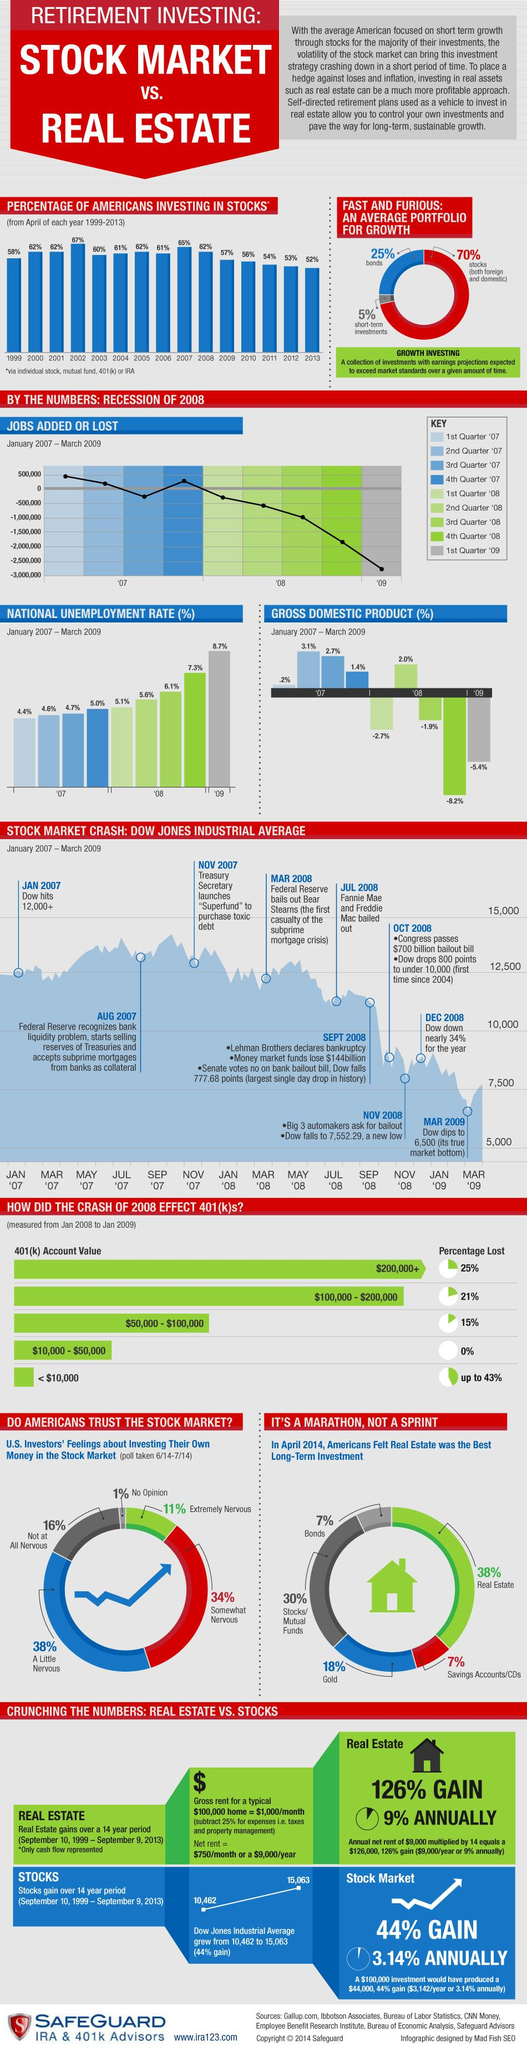Point out several critical features in this image. The 3rd quarter of 2008 shows a loss of 1,000,000 jobs. On November 2008, the Dow Jones Industrial Average fell to a value of 7552.29, which was also the case during the months of March and September of the same year. The sources indicate that jobs were added in the 1st Quarter of 2007, the 2nd Quarter of 2007, and the 4th Quarter of 2007. According to a recent survey, 83% of Americans are nervous about investing in the stock market. In 2012, American investors recorded the second lowest percentage of investment in stocks out of any year on record. 